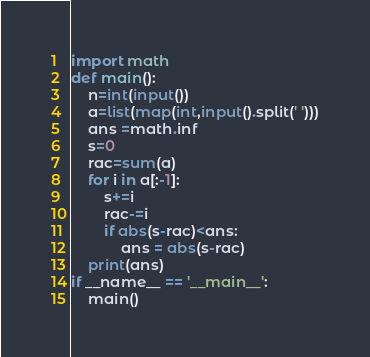<code> <loc_0><loc_0><loc_500><loc_500><_Python_>import math
def main():
    n=int(input())
    a=list(map(int,input().split(' ')))
    ans =math.inf
    s=0
    rac=sum(a)
    for i in a[:-1]:
        s+=i
        rac-=i
        if abs(s-rac)<ans:
            ans = abs(s-rac)
    print(ans)
if __name__ == '__main__':
    main()
</code> 